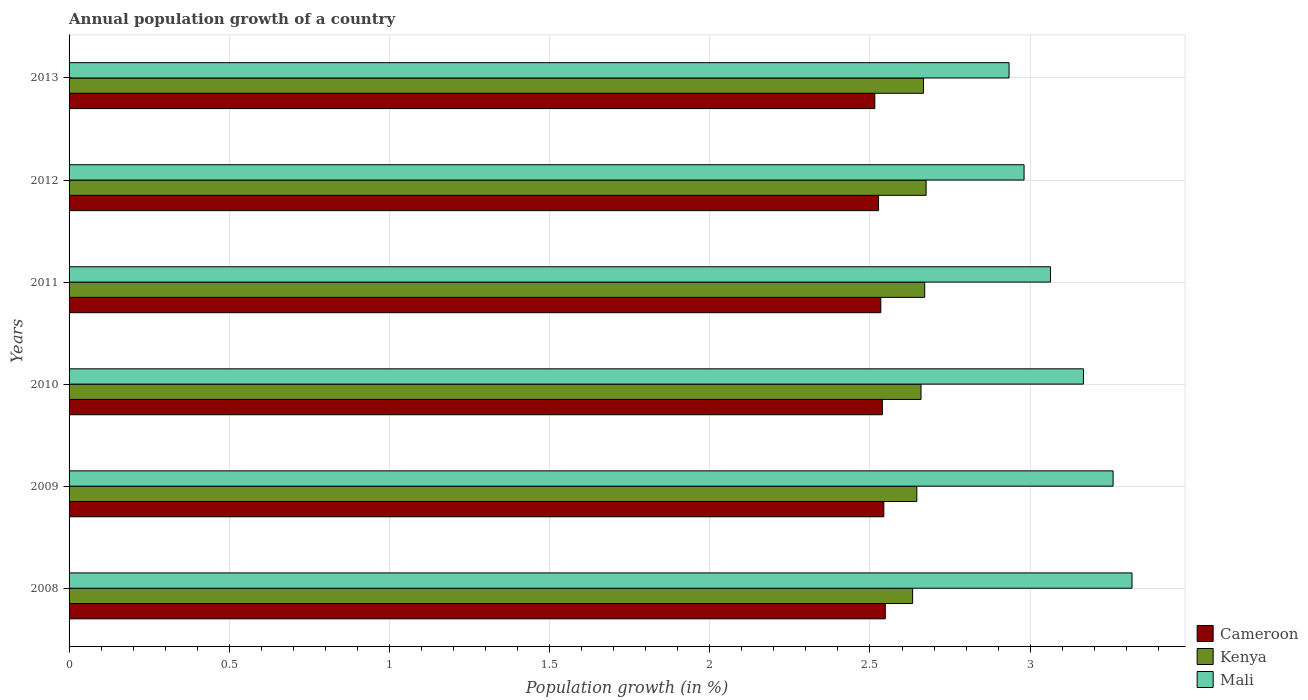How many different coloured bars are there?
Give a very brief answer. 3. Are the number of bars on each tick of the Y-axis equal?
Provide a short and direct response. Yes. What is the label of the 3rd group of bars from the top?
Offer a very short reply. 2011. What is the annual population growth in Kenya in 2009?
Give a very brief answer. 2.65. Across all years, what is the maximum annual population growth in Mali?
Provide a succinct answer. 3.32. Across all years, what is the minimum annual population growth in Kenya?
Your answer should be compact. 2.63. In which year was the annual population growth in Kenya maximum?
Your response must be concise. 2012. In which year was the annual population growth in Mali minimum?
Your response must be concise. 2013. What is the total annual population growth in Kenya in the graph?
Your answer should be very brief. 15.95. What is the difference between the annual population growth in Cameroon in 2009 and that in 2010?
Provide a short and direct response. 0. What is the difference between the annual population growth in Cameroon in 2010 and the annual population growth in Mali in 2013?
Your answer should be compact. -0.4. What is the average annual population growth in Cameroon per year?
Offer a terse response. 2.53. In the year 2011, what is the difference between the annual population growth in Kenya and annual population growth in Mali?
Your answer should be compact. -0.39. In how many years, is the annual population growth in Mali greater than 2.8 %?
Provide a succinct answer. 6. What is the ratio of the annual population growth in Cameroon in 2009 to that in 2012?
Make the answer very short. 1.01. Is the annual population growth in Cameroon in 2010 less than that in 2013?
Provide a succinct answer. No. Is the difference between the annual population growth in Kenya in 2008 and 2012 greater than the difference between the annual population growth in Mali in 2008 and 2012?
Your response must be concise. No. What is the difference between the highest and the second highest annual population growth in Mali?
Offer a terse response. 0.06. What is the difference between the highest and the lowest annual population growth in Cameroon?
Offer a very short reply. 0.03. In how many years, is the annual population growth in Cameroon greater than the average annual population growth in Cameroon taken over all years?
Give a very brief answer. 3. What does the 2nd bar from the top in 2008 represents?
Offer a terse response. Kenya. What does the 2nd bar from the bottom in 2013 represents?
Offer a terse response. Kenya. How many bars are there?
Keep it short and to the point. 18. Are the values on the major ticks of X-axis written in scientific E-notation?
Provide a succinct answer. No. Where does the legend appear in the graph?
Offer a very short reply. Bottom right. How many legend labels are there?
Give a very brief answer. 3. How are the legend labels stacked?
Provide a succinct answer. Vertical. What is the title of the graph?
Your answer should be very brief. Annual population growth of a country. Does "Other small states" appear as one of the legend labels in the graph?
Provide a short and direct response. No. What is the label or title of the X-axis?
Keep it short and to the point. Population growth (in %). What is the Population growth (in %) in Cameroon in 2008?
Give a very brief answer. 2.55. What is the Population growth (in %) of Kenya in 2008?
Ensure brevity in your answer.  2.63. What is the Population growth (in %) of Mali in 2008?
Your response must be concise. 3.32. What is the Population growth (in %) of Cameroon in 2009?
Your response must be concise. 2.54. What is the Population growth (in %) of Kenya in 2009?
Offer a terse response. 2.65. What is the Population growth (in %) of Mali in 2009?
Offer a terse response. 3.26. What is the Population growth (in %) of Cameroon in 2010?
Provide a succinct answer. 2.54. What is the Population growth (in %) of Kenya in 2010?
Give a very brief answer. 2.66. What is the Population growth (in %) in Mali in 2010?
Your response must be concise. 3.17. What is the Population growth (in %) in Cameroon in 2011?
Provide a succinct answer. 2.53. What is the Population growth (in %) of Kenya in 2011?
Keep it short and to the point. 2.67. What is the Population growth (in %) in Mali in 2011?
Your response must be concise. 3.06. What is the Population growth (in %) in Cameroon in 2012?
Provide a succinct answer. 2.53. What is the Population growth (in %) of Kenya in 2012?
Your response must be concise. 2.68. What is the Population growth (in %) in Mali in 2012?
Give a very brief answer. 2.98. What is the Population growth (in %) of Cameroon in 2013?
Give a very brief answer. 2.52. What is the Population growth (in %) in Kenya in 2013?
Offer a very short reply. 2.67. What is the Population growth (in %) in Mali in 2013?
Offer a terse response. 2.93. Across all years, what is the maximum Population growth (in %) of Cameroon?
Make the answer very short. 2.55. Across all years, what is the maximum Population growth (in %) of Kenya?
Your response must be concise. 2.68. Across all years, what is the maximum Population growth (in %) of Mali?
Offer a very short reply. 3.32. Across all years, what is the minimum Population growth (in %) in Cameroon?
Give a very brief answer. 2.52. Across all years, what is the minimum Population growth (in %) in Kenya?
Give a very brief answer. 2.63. Across all years, what is the minimum Population growth (in %) of Mali?
Make the answer very short. 2.93. What is the total Population growth (in %) in Cameroon in the graph?
Offer a terse response. 15.21. What is the total Population growth (in %) of Kenya in the graph?
Your answer should be compact. 15.95. What is the total Population growth (in %) in Mali in the graph?
Offer a very short reply. 18.72. What is the difference between the Population growth (in %) of Cameroon in 2008 and that in 2009?
Ensure brevity in your answer.  0. What is the difference between the Population growth (in %) of Kenya in 2008 and that in 2009?
Offer a terse response. -0.01. What is the difference between the Population growth (in %) in Mali in 2008 and that in 2009?
Your response must be concise. 0.06. What is the difference between the Population growth (in %) of Cameroon in 2008 and that in 2010?
Your answer should be very brief. 0.01. What is the difference between the Population growth (in %) of Kenya in 2008 and that in 2010?
Give a very brief answer. -0.03. What is the difference between the Population growth (in %) in Mali in 2008 and that in 2010?
Your answer should be compact. 0.15. What is the difference between the Population growth (in %) of Cameroon in 2008 and that in 2011?
Your response must be concise. 0.01. What is the difference between the Population growth (in %) in Kenya in 2008 and that in 2011?
Offer a very short reply. -0.04. What is the difference between the Population growth (in %) of Mali in 2008 and that in 2011?
Provide a short and direct response. 0.25. What is the difference between the Population growth (in %) of Cameroon in 2008 and that in 2012?
Give a very brief answer. 0.02. What is the difference between the Population growth (in %) in Kenya in 2008 and that in 2012?
Your answer should be compact. -0.04. What is the difference between the Population growth (in %) in Mali in 2008 and that in 2012?
Your answer should be compact. 0.34. What is the difference between the Population growth (in %) of Cameroon in 2008 and that in 2013?
Ensure brevity in your answer.  0.03. What is the difference between the Population growth (in %) in Kenya in 2008 and that in 2013?
Provide a short and direct response. -0.03. What is the difference between the Population growth (in %) of Mali in 2008 and that in 2013?
Provide a succinct answer. 0.38. What is the difference between the Population growth (in %) in Cameroon in 2009 and that in 2010?
Your answer should be very brief. 0. What is the difference between the Population growth (in %) of Kenya in 2009 and that in 2010?
Offer a terse response. -0.01. What is the difference between the Population growth (in %) in Mali in 2009 and that in 2010?
Provide a succinct answer. 0.09. What is the difference between the Population growth (in %) in Cameroon in 2009 and that in 2011?
Your answer should be very brief. 0.01. What is the difference between the Population growth (in %) in Kenya in 2009 and that in 2011?
Keep it short and to the point. -0.02. What is the difference between the Population growth (in %) in Mali in 2009 and that in 2011?
Offer a terse response. 0.2. What is the difference between the Population growth (in %) in Cameroon in 2009 and that in 2012?
Keep it short and to the point. 0.02. What is the difference between the Population growth (in %) in Kenya in 2009 and that in 2012?
Offer a terse response. -0.03. What is the difference between the Population growth (in %) of Mali in 2009 and that in 2012?
Offer a terse response. 0.28. What is the difference between the Population growth (in %) of Cameroon in 2009 and that in 2013?
Keep it short and to the point. 0.03. What is the difference between the Population growth (in %) in Kenya in 2009 and that in 2013?
Ensure brevity in your answer.  -0.02. What is the difference between the Population growth (in %) of Mali in 2009 and that in 2013?
Offer a terse response. 0.32. What is the difference between the Population growth (in %) in Cameroon in 2010 and that in 2011?
Make the answer very short. 0. What is the difference between the Population growth (in %) of Kenya in 2010 and that in 2011?
Your answer should be compact. -0.01. What is the difference between the Population growth (in %) of Mali in 2010 and that in 2011?
Ensure brevity in your answer.  0.1. What is the difference between the Population growth (in %) of Cameroon in 2010 and that in 2012?
Keep it short and to the point. 0.01. What is the difference between the Population growth (in %) of Kenya in 2010 and that in 2012?
Your answer should be compact. -0.02. What is the difference between the Population growth (in %) of Mali in 2010 and that in 2012?
Your answer should be very brief. 0.19. What is the difference between the Population growth (in %) of Cameroon in 2010 and that in 2013?
Your answer should be very brief. 0.02. What is the difference between the Population growth (in %) in Kenya in 2010 and that in 2013?
Offer a very short reply. -0.01. What is the difference between the Population growth (in %) of Mali in 2010 and that in 2013?
Give a very brief answer. 0.23. What is the difference between the Population growth (in %) in Cameroon in 2011 and that in 2012?
Your answer should be very brief. 0.01. What is the difference between the Population growth (in %) in Kenya in 2011 and that in 2012?
Provide a succinct answer. -0. What is the difference between the Population growth (in %) in Mali in 2011 and that in 2012?
Your response must be concise. 0.08. What is the difference between the Population growth (in %) of Cameroon in 2011 and that in 2013?
Your response must be concise. 0.02. What is the difference between the Population growth (in %) of Kenya in 2011 and that in 2013?
Offer a very short reply. 0. What is the difference between the Population growth (in %) of Mali in 2011 and that in 2013?
Make the answer very short. 0.13. What is the difference between the Population growth (in %) in Cameroon in 2012 and that in 2013?
Offer a very short reply. 0.01. What is the difference between the Population growth (in %) in Kenya in 2012 and that in 2013?
Provide a succinct answer. 0.01. What is the difference between the Population growth (in %) of Mali in 2012 and that in 2013?
Provide a succinct answer. 0.05. What is the difference between the Population growth (in %) of Cameroon in 2008 and the Population growth (in %) of Kenya in 2009?
Your answer should be very brief. -0.1. What is the difference between the Population growth (in %) of Cameroon in 2008 and the Population growth (in %) of Mali in 2009?
Your answer should be very brief. -0.71. What is the difference between the Population growth (in %) in Kenya in 2008 and the Population growth (in %) in Mali in 2009?
Provide a succinct answer. -0.63. What is the difference between the Population growth (in %) of Cameroon in 2008 and the Population growth (in %) of Kenya in 2010?
Give a very brief answer. -0.11. What is the difference between the Population growth (in %) of Cameroon in 2008 and the Population growth (in %) of Mali in 2010?
Provide a succinct answer. -0.62. What is the difference between the Population growth (in %) in Kenya in 2008 and the Population growth (in %) in Mali in 2010?
Offer a terse response. -0.53. What is the difference between the Population growth (in %) of Cameroon in 2008 and the Population growth (in %) of Kenya in 2011?
Offer a very short reply. -0.12. What is the difference between the Population growth (in %) in Cameroon in 2008 and the Population growth (in %) in Mali in 2011?
Make the answer very short. -0.52. What is the difference between the Population growth (in %) of Kenya in 2008 and the Population growth (in %) of Mali in 2011?
Offer a terse response. -0.43. What is the difference between the Population growth (in %) in Cameroon in 2008 and the Population growth (in %) in Kenya in 2012?
Offer a very short reply. -0.13. What is the difference between the Population growth (in %) of Cameroon in 2008 and the Population growth (in %) of Mali in 2012?
Offer a very short reply. -0.43. What is the difference between the Population growth (in %) of Kenya in 2008 and the Population growth (in %) of Mali in 2012?
Give a very brief answer. -0.35. What is the difference between the Population growth (in %) in Cameroon in 2008 and the Population growth (in %) in Kenya in 2013?
Provide a succinct answer. -0.12. What is the difference between the Population growth (in %) in Cameroon in 2008 and the Population growth (in %) in Mali in 2013?
Provide a short and direct response. -0.39. What is the difference between the Population growth (in %) in Kenya in 2008 and the Population growth (in %) in Mali in 2013?
Give a very brief answer. -0.3. What is the difference between the Population growth (in %) in Cameroon in 2009 and the Population growth (in %) in Kenya in 2010?
Offer a terse response. -0.12. What is the difference between the Population growth (in %) in Cameroon in 2009 and the Population growth (in %) in Mali in 2010?
Your answer should be compact. -0.62. What is the difference between the Population growth (in %) in Kenya in 2009 and the Population growth (in %) in Mali in 2010?
Keep it short and to the point. -0.52. What is the difference between the Population growth (in %) of Cameroon in 2009 and the Population growth (in %) of Kenya in 2011?
Make the answer very short. -0.13. What is the difference between the Population growth (in %) of Cameroon in 2009 and the Population growth (in %) of Mali in 2011?
Your answer should be very brief. -0.52. What is the difference between the Population growth (in %) of Kenya in 2009 and the Population growth (in %) of Mali in 2011?
Your answer should be compact. -0.42. What is the difference between the Population growth (in %) in Cameroon in 2009 and the Population growth (in %) in Kenya in 2012?
Your response must be concise. -0.13. What is the difference between the Population growth (in %) of Cameroon in 2009 and the Population growth (in %) of Mali in 2012?
Provide a short and direct response. -0.44. What is the difference between the Population growth (in %) in Kenya in 2009 and the Population growth (in %) in Mali in 2012?
Offer a terse response. -0.33. What is the difference between the Population growth (in %) of Cameroon in 2009 and the Population growth (in %) of Kenya in 2013?
Provide a short and direct response. -0.12. What is the difference between the Population growth (in %) in Cameroon in 2009 and the Population growth (in %) in Mali in 2013?
Provide a short and direct response. -0.39. What is the difference between the Population growth (in %) of Kenya in 2009 and the Population growth (in %) of Mali in 2013?
Give a very brief answer. -0.29. What is the difference between the Population growth (in %) of Cameroon in 2010 and the Population growth (in %) of Kenya in 2011?
Your response must be concise. -0.13. What is the difference between the Population growth (in %) in Cameroon in 2010 and the Population growth (in %) in Mali in 2011?
Give a very brief answer. -0.52. What is the difference between the Population growth (in %) of Kenya in 2010 and the Population growth (in %) of Mali in 2011?
Your answer should be compact. -0.4. What is the difference between the Population growth (in %) in Cameroon in 2010 and the Population growth (in %) in Kenya in 2012?
Offer a very short reply. -0.14. What is the difference between the Population growth (in %) of Cameroon in 2010 and the Population growth (in %) of Mali in 2012?
Your answer should be compact. -0.44. What is the difference between the Population growth (in %) of Kenya in 2010 and the Population growth (in %) of Mali in 2012?
Offer a very short reply. -0.32. What is the difference between the Population growth (in %) in Cameroon in 2010 and the Population growth (in %) in Kenya in 2013?
Offer a very short reply. -0.13. What is the difference between the Population growth (in %) in Cameroon in 2010 and the Population growth (in %) in Mali in 2013?
Your response must be concise. -0.4. What is the difference between the Population growth (in %) of Kenya in 2010 and the Population growth (in %) of Mali in 2013?
Your response must be concise. -0.27. What is the difference between the Population growth (in %) in Cameroon in 2011 and the Population growth (in %) in Kenya in 2012?
Your answer should be compact. -0.14. What is the difference between the Population growth (in %) in Cameroon in 2011 and the Population growth (in %) in Mali in 2012?
Provide a short and direct response. -0.45. What is the difference between the Population growth (in %) in Kenya in 2011 and the Population growth (in %) in Mali in 2012?
Offer a terse response. -0.31. What is the difference between the Population growth (in %) of Cameroon in 2011 and the Population growth (in %) of Kenya in 2013?
Give a very brief answer. -0.13. What is the difference between the Population growth (in %) in Cameroon in 2011 and the Population growth (in %) in Mali in 2013?
Offer a terse response. -0.4. What is the difference between the Population growth (in %) in Kenya in 2011 and the Population growth (in %) in Mali in 2013?
Your answer should be compact. -0.26. What is the difference between the Population growth (in %) of Cameroon in 2012 and the Population growth (in %) of Kenya in 2013?
Provide a succinct answer. -0.14. What is the difference between the Population growth (in %) in Cameroon in 2012 and the Population growth (in %) in Mali in 2013?
Your answer should be compact. -0.41. What is the difference between the Population growth (in %) of Kenya in 2012 and the Population growth (in %) of Mali in 2013?
Your response must be concise. -0.26. What is the average Population growth (in %) of Cameroon per year?
Keep it short and to the point. 2.53. What is the average Population growth (in %) in Kenya per year?
Offer a terse response. 2.66. What is the average Population growth (in %) in Mali per year?
Your answer should be very brief. 3.12. In the year 2008, what is the difference between the Population growth (in %) of Cameroon and Population growth (in %) of Kenya?
Your response must be concise. -0.09. In the year 2008, what is the difference between the Population growth (in %) of Cameroon and Population growth (in %) of Mali?
Provide a succinct answer. -0.77. In the year 2008, what is the difference between the Population growth (in %) of Kenya and Population growth (in %) of Mali?
Offer a terse response. -0.68. In the year 2009, what is the difference between the Population growth (in %) of Cameroon and Population growth (in %) of Kenya?
Provide a short and direct response. -0.1. In the year 2009, what is the difference between the Population growth (in %) of Cameroon and Population growth (in %) of Mali?
Your answer should be compact. -0.72. In the year 2009, what is the difference between the Population growth (in %) in Kenya and Population growth (in %) in Mali?
Provide a short and direct response. -0.61. In the year 2010, what is the difference between the Population growth (in %) of Cameroon and Population growth (in %) of Kenya?
Offer a very short reply. -0.12. In the year 2010, what is the difference between the Population growth (in %) in Cameroon and Population growth (in %) in Mali?
Give a very brief answer. -0.63. In the year 2010, what is the difference between the Population growth (in %) of Kenya and Population growth (in %) of Mali?
Provide a short and direct response. -0.51. In the year 2011, what is the difference between the Population growth (in %) in Cameroon and Population growth (in %) in Kenya?
Ensure brevity in your answer.  -0.14. In the year 2011, what is the difference between the Population growth (in %) in Cameroon and Population growth (in %) in Mali?
Give a very brief answer. -0.53. In the year 2011, what is the difference between the Population growth (in %) in Kenya and Population growth (in %) in Mali?
Offer a terse response. -0.39. In the year 2012, what is the difference between the Population growth (in %) of Cameroon and Population growth (in %) of Kenya?
Your answer should be compact. -0.15. In the year 2012, what is the difference between the Population growth (in %) of Cameroon and Population growth (in %) of Mali?
Give a very brief answer. -0.45. In the year 2012, what is the difference between the Population growth (in %) of Kenya and Population growth (in %) of Mali?
Provide a succinct answer. -0.31. In the year 2013, what is the difference between the Population growth (in %) of Cameroon and Population growth (in %) of Kenya?
Give a very brief answer. -0.15. In the year 2013, what is the difference between the Population growth (in %) of Cameroon and Population growth (in %) of Mali?
Give a very brief answer. -0.42. In the year 2013, what is the difference between the Population growth (in %) in Kenya and Population growth (in %) in Mali?
Your answer should be compact. -0.27. What is the ratio of the Population growth (in %) in Cameroon in 2008 to that in 2009?
Keep it short and to the point. 1. What is the ratio of the Population growth (in %) in Kenya in 2008 to that in 2009?
Keep it short and to the point. 1. What is the ratio of the Population growth (in %) of Mali in 2008 to that in 2009?
Provide a succinct answer. 1.02. What is the ratio of the Population growth (in %) in Kenya in 2008 to that in 2010?
Ensure brevity in your answer.  0.99. What is the ratio of the Population growth (in %) in Mali in 2008 to that in 2010?
Ensure brevity in your answer.  1.05. What is the ratio of the Population growth (in %) of Kenya in 2008 to that in 2011?
Provide a succinct answer. 0.99. What is the ratio of the Population growth (in %) in Mali in 2008 to that in 2011?
Your response must be concise. 1.08. What is the ratio of the Population growth (in %) of Cameroon in 2008 to that in 2012?
Your response must be concise. 1.01. What is the ratio of the Population growth (in %) in Kenya in 2008 to that in 2012?
Provide a short and direct response. 0.98. What is the ratio of the Population growth (in %) of Mali in 2008 to that in 2012?
Give a very brief answer. 1.11. What is the ratio of the Population growth (in %) in Cameroon in 2008 to that in 2013?
Ensure brevity in your answer.  1.01. What is the ratio of the Population growth (in %) of Kenya in 2008 to that in 2013?
Offer a very short reply. 0.99. What is the ratio of the Population growth (in %) in Mali in 2008 to that in 2013?
Your answer should be compact. 1.13. What is the ratio of the Population growth (in %) of Cameroon in 2009 to that in 2010?
Offer a very short reply. 1. What is the ratio of the Population growth (in %) in Mali in 2009 to that in 2010?
Your response must be concise. 1.03. What is the ratio of the Population growth (in %) of Mali in 2009 to that in 2011?
Offer a very short reply. 1.06. What is the ratio of the Population growth (in %) in Cameroon in 2009 to that in 2012?
Provide a short and direct response. 1.01. What is the ratio of the Population growth (in %) in Mali in 2009 to that in 2012?
Your answer should be very brief. 1.09. What is the ratio of the Population growth (in %) of Cameroon in 2009 to that in 2013?
Ensure brevity in your answer.  1.01. What is the ratio of the Population growth (in %) of Kenya in 2009 to that in 2013?
Give a very brief answer. 0.99. What is the ratio of the Population growth (in %) in Mali in 2009 to that in 2013?
Offer a terse response. 1.11. What is the ratio of the Population growth (in %) of Cameroon in 2010 to that in 2011?
Ensure brevity in your answer.  1. What is the ratio of the Population growth (in %) in Mali in 2010 to that in 2011?
Your answer should be very brief. 1.03. What is the ratio of the Population growth (in %) of Cameroon in 2010 to that in 2012?
Offer a terse response. 1. What is the ratio of the Population growth (in %) of Kenya in 2010 to that in 2012?
Offer a terse response. 0.99. What is the ratio of the Population growth (in %) of Mali in 2010 to that in 2012?
Provide a short and direct response. 1.06. What is the ratio of the Population growth (in %) of Cameroon in 2010 to that in 2013?
Give a very brief answer. 1.01. What is the ratio of the Population growth (in %) in Mali in 2010 to that in 2013?
Keep it short and to the point. 1.08. What is the ratio of the Population growth (in %) in Cameroon in 2011 to that in 2012?
Your response must be concise. 1. What is the ratio of the Population growth (in %) of Mali in 2011 to that in 2012?
Provide a short and direct response. 1.03. What is the ratio of the Population growth (in %) in Cameroon in 2011 to that in 2013?
Offer a very short reply. 1.01. What is the ratio of the Population growth (in %) of Kenya in 2011 to that in 2013?
Your response must be concise. 1. What is the ratio of the Population growth (in %) of Mali in 2011 to that in 2013?
Your response must be concise. 1.04. What is the ratio of the Population growth (in %) in Mali in 2012 to that in 2013?
Make the answer very short. 1.02. What is the difference between the highest and the second highest Population growth (in %) in Cameroon?
Offer a terse response. 0. What is the difference between the highest and the second highest Population growth (in %) of Kenya?
Your answer should be compact. 0. What is the difference between the highest and the second highest Population growth (in %) of Mali?
Give a very brief answer. 0.06. What is the difference between the highest and the lowest Population growth (in %) of Cameroon?
Ensure brevity in your answer.  0.03. What is the difference between the highest and the lowest Population growth (in %) in Kenya?
Offer a terse response. 0.04. What is the difference between the highest and the lowest Population growth (in %) in Mali?
Your answer should be very brief. 0.38. 